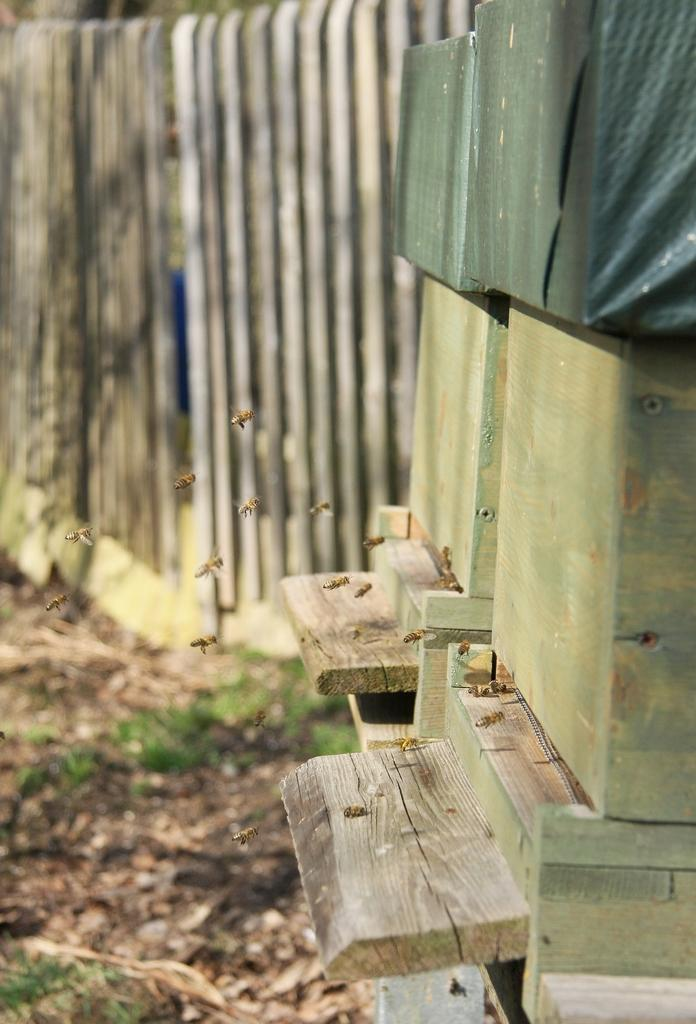What type of insects can be seen in the image? There are honey bees in the image. What objects are also present in the image? There are wooden blocks in the image. What can be seen in the background of the image? There is fencing and grass in the background of the image. What type of doctor is attending to the honey bees in the image? There is no doctor present in the image; it features honey bees and wooden blocks. What color is the sun in the image? The sun is not visible in the image, so its color cannot be determined. 